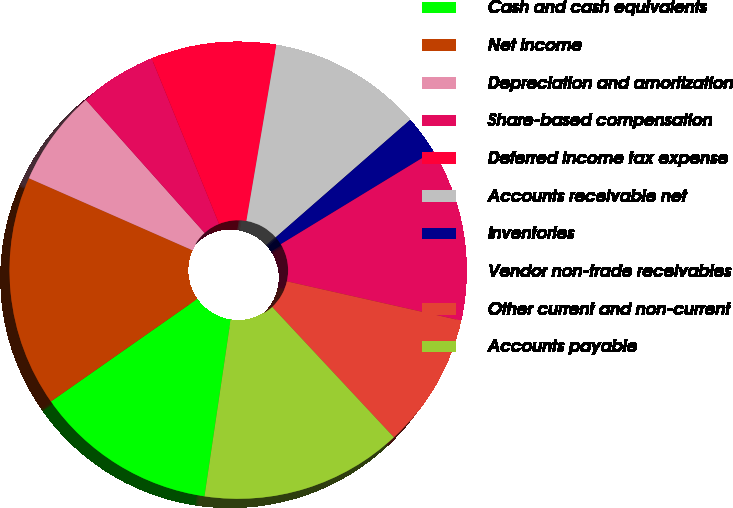Convert chart. <chart><loc_0><loc_0><loc_500><loc_500><pie_chart><fcel>Cash and cash equivalents<fcel>Net income<fcel>Depreciation and amortization<fcel>Share-based compensation<fcel>Deferred income tax expense<fcel>Accounts receivable net<fcel>Inventories<fcel>Vendor non-trade receivables<fcel>Other current and non-current<fcel>Accounts payable<nl><fcel>12.93%<fcel>16.33%<fcel>6.8%<fcel>5.44%<fcel>8.84%<fcel>10.88%<fcel>2.72%<fcel>12.24%<fcel>9.52%<fcel>14.29%<nl></chart> 